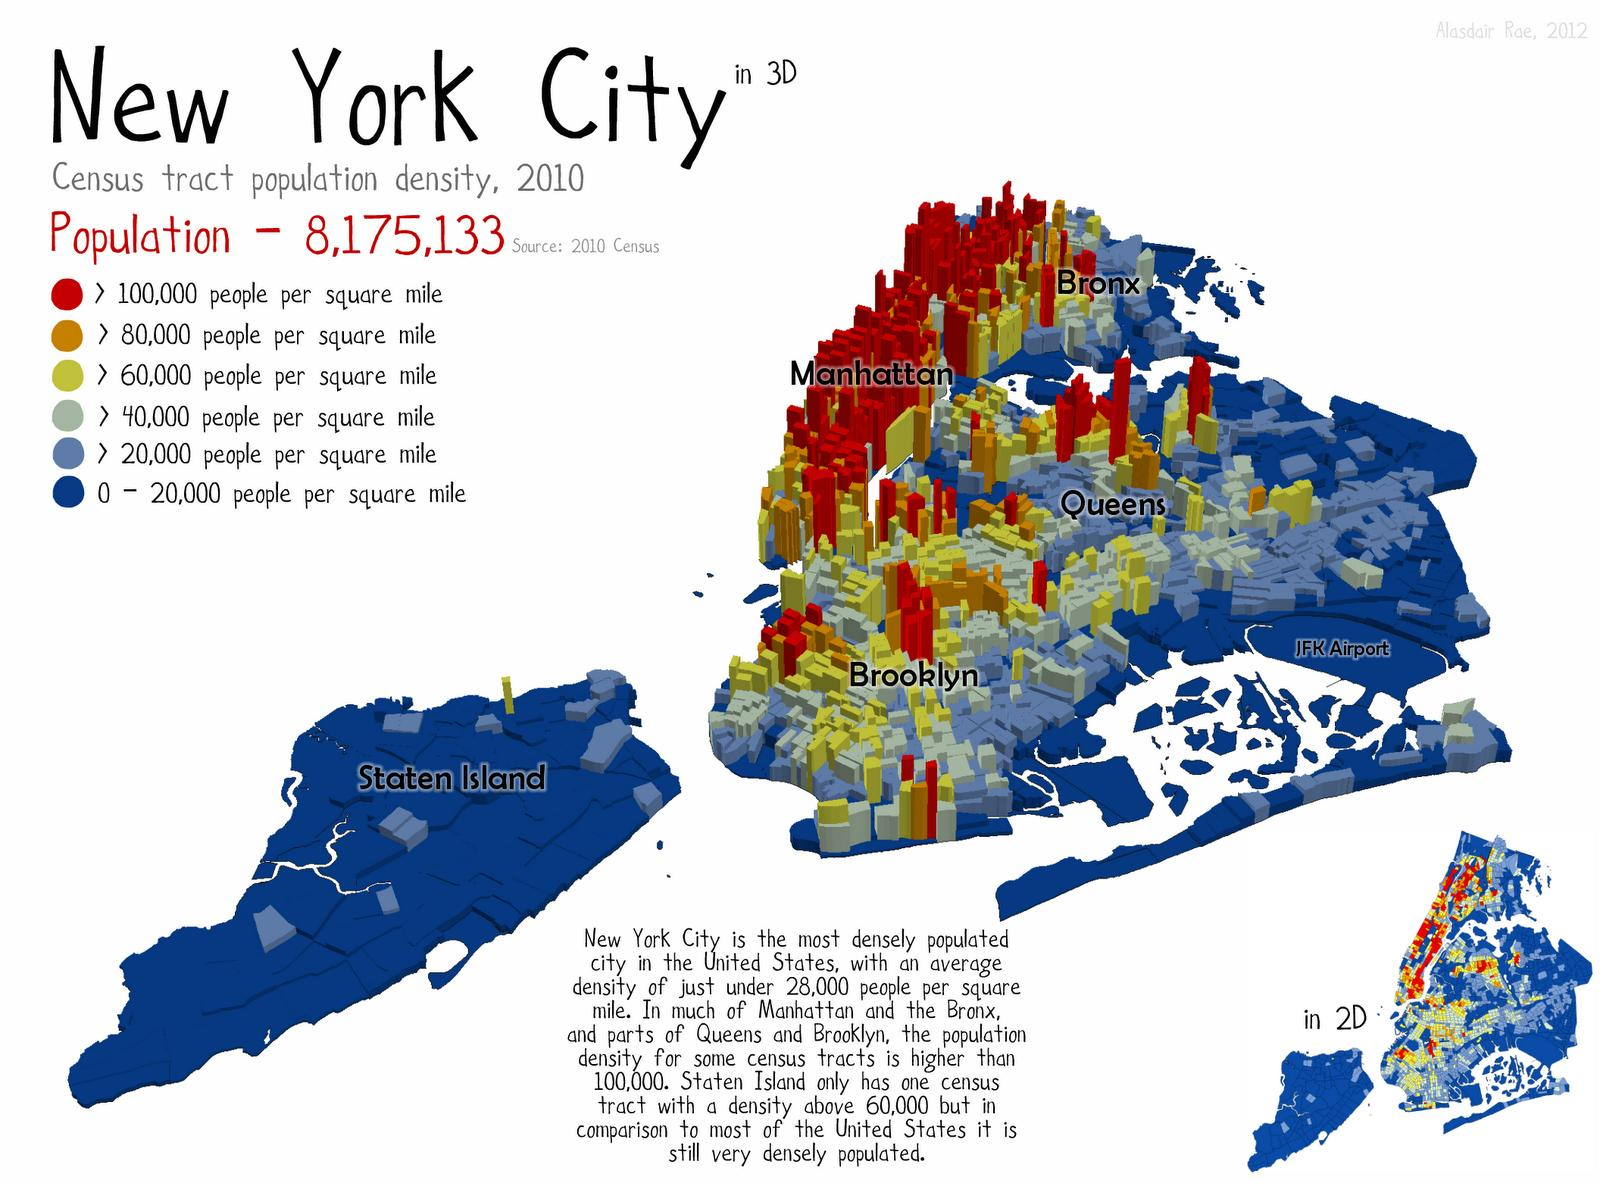Point out several critical features in this image. There are six categories of the population mentioned in this infographic. 